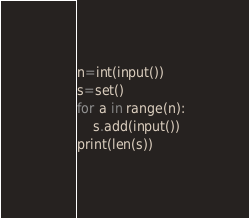Convert code to text. <code><loc_0><loc_0><loc_500><loc_500><_Python_>n=int(input())
s=set()
for a in range(n):
    s.add(input())
print(len(s))</code> 